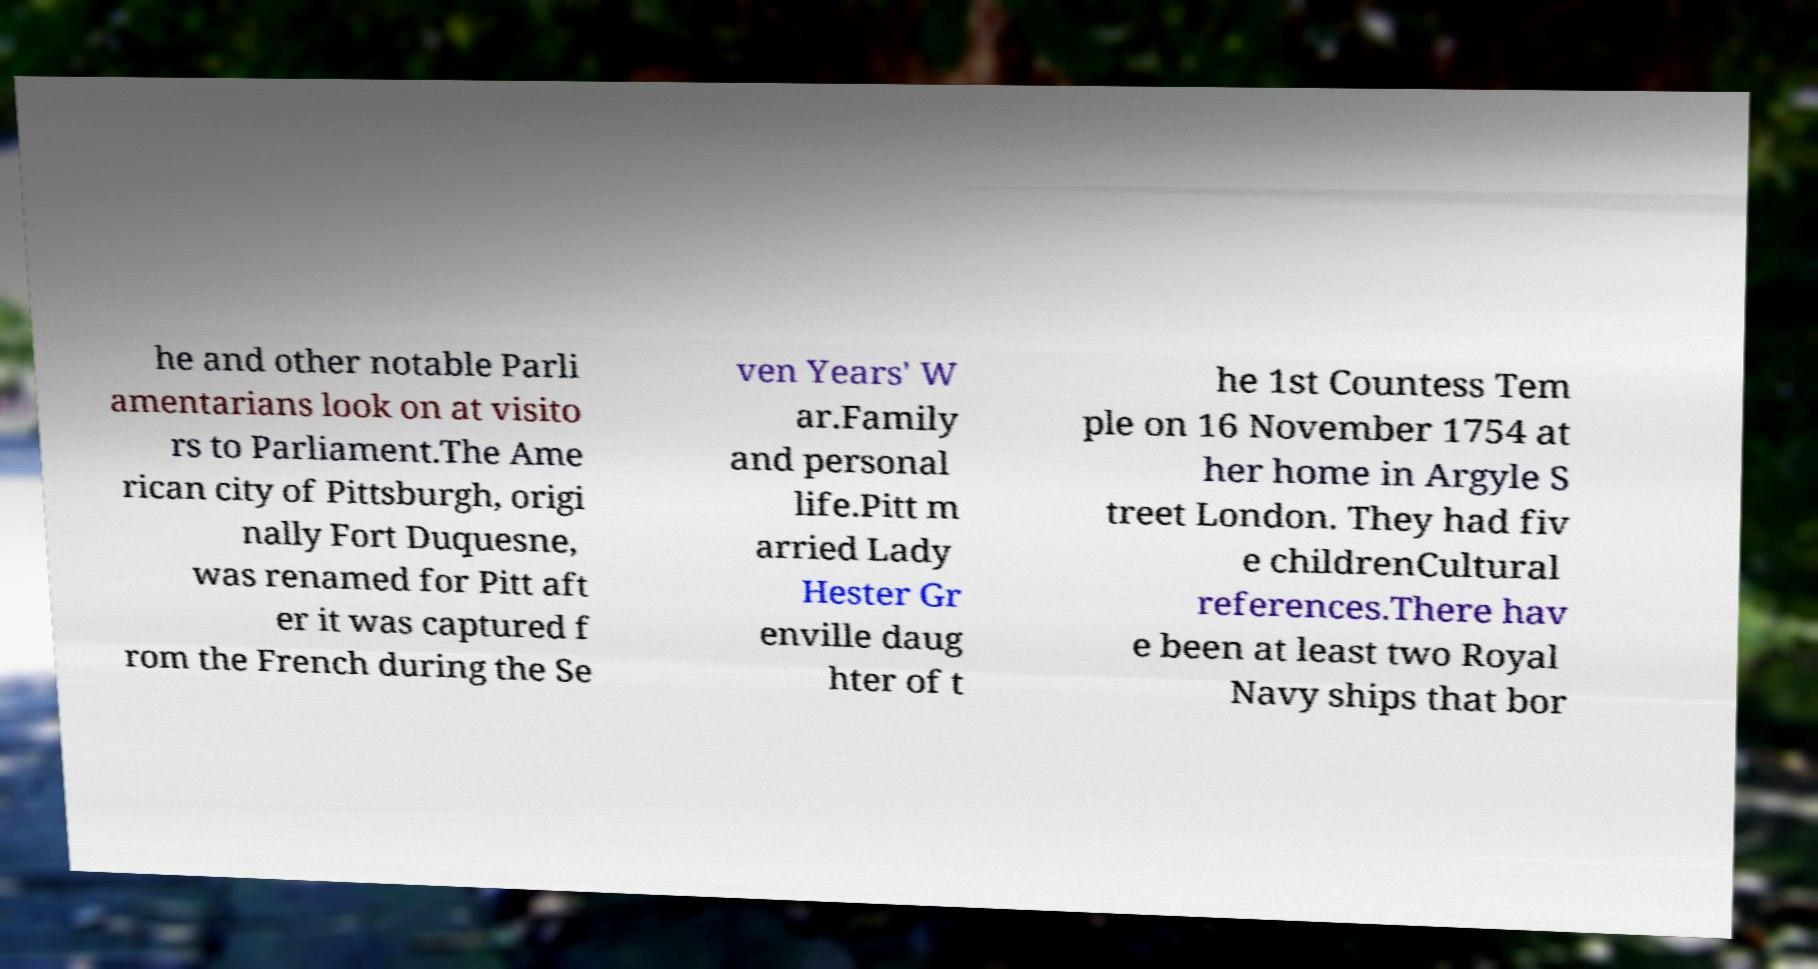Can you read and provide the text displayed in the image?This photo seems to have some interesting text. Can you extract and type it out for me? he and other notable Parli amentarians look on at visito rs to Parliament.The Ame rican city of Pittsburgh, origi nally Fort Duquesne, was renamed for Pitt aft er it was captured f rom the French during the Se ven Years' W ar.Family and personal life.Pitt m arried Lady Hester Gr enville daug hter of t he 1st Countess Tem ple on 16 November 1754 at her home in Argyle S treet London. They had fiv e childrenCultural references.There hav e been at least two Royal Navy ships that bor 